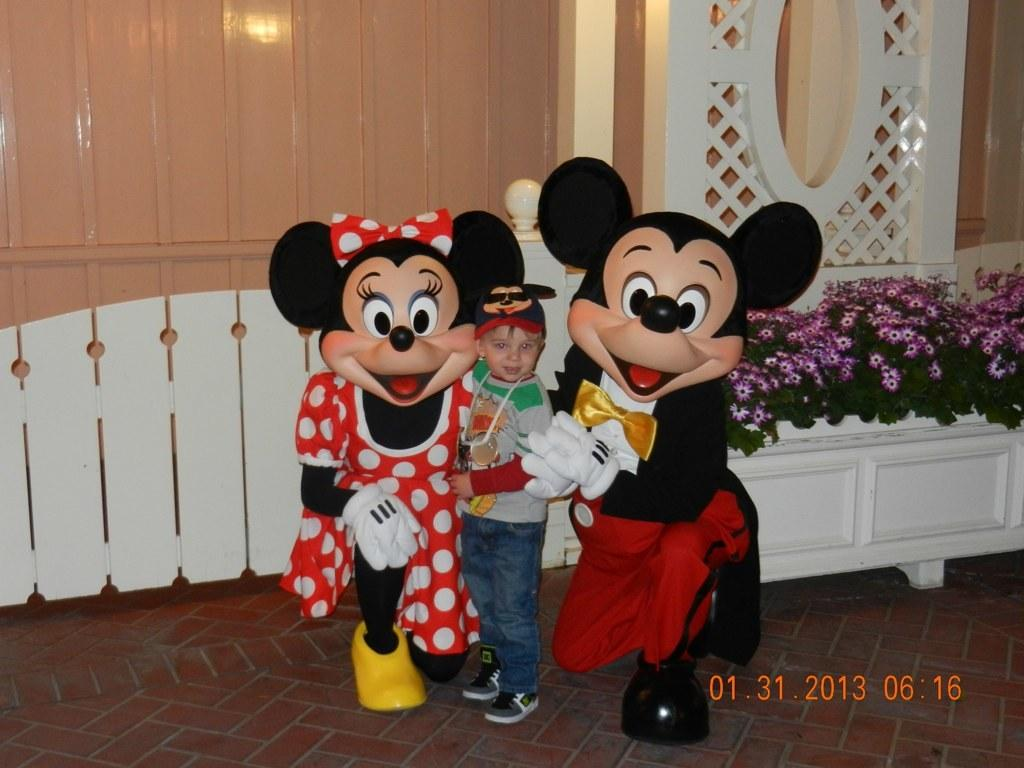What are the kids in the image wearing? The kids in the image are wearing masks. Can you describe the position of the boy in the image? There is a boy standing in the middle of the kids. What is the boy wearing on his head? The boy is wearing a cap. What can be seen in the background of the image? There is a building visible in the image. What type of vegetation is present in the image? There are plants with flowers in the image. Can you tell me how many appliances are visible in the image? There are no appliances visible in the image. Are there any planes flying in the sky in the image? There is no sky or planes visible in the image. 